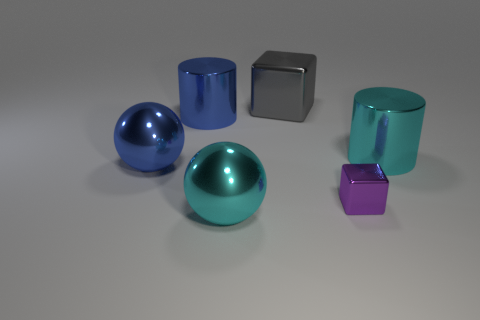How many other tiny metallic blocks are the same color as the tiny cube?
Your answer should be compact. 0. What shape is the cyan shiny thing behind the block in front of the large blue metal ball?
Provide a succinct answer. Cylinder. Is there another gray shiny thing of the same shape as the tiny object?
Provide a succinct answer. Yes. There is a small block; is its color the same as the large shiny object that is right of the small shiny block?
Give a very brief answer. No. Are there any blue shiny cylinders that have the same size as the gray metal object?
Provide a short and direct response. Yes. Is the number of big cyan balls greater than the number of balls?
Ensure brevity in your answer.  No. What number of blocks are either big metallic things or big red objects?
Your answer should be compact. 1. The tiny object has what color?
Your answer should be compact. Purple. Does the cyan thing that is to the left of the big gray metallic cube have the same size as the cyan shiny thing that is right of the purple metallic cube?
Make the answer very short. Yes. Are there fewer big blue metallic balls than small yellow shiny cubes?
Keep it short and to the point. No. 